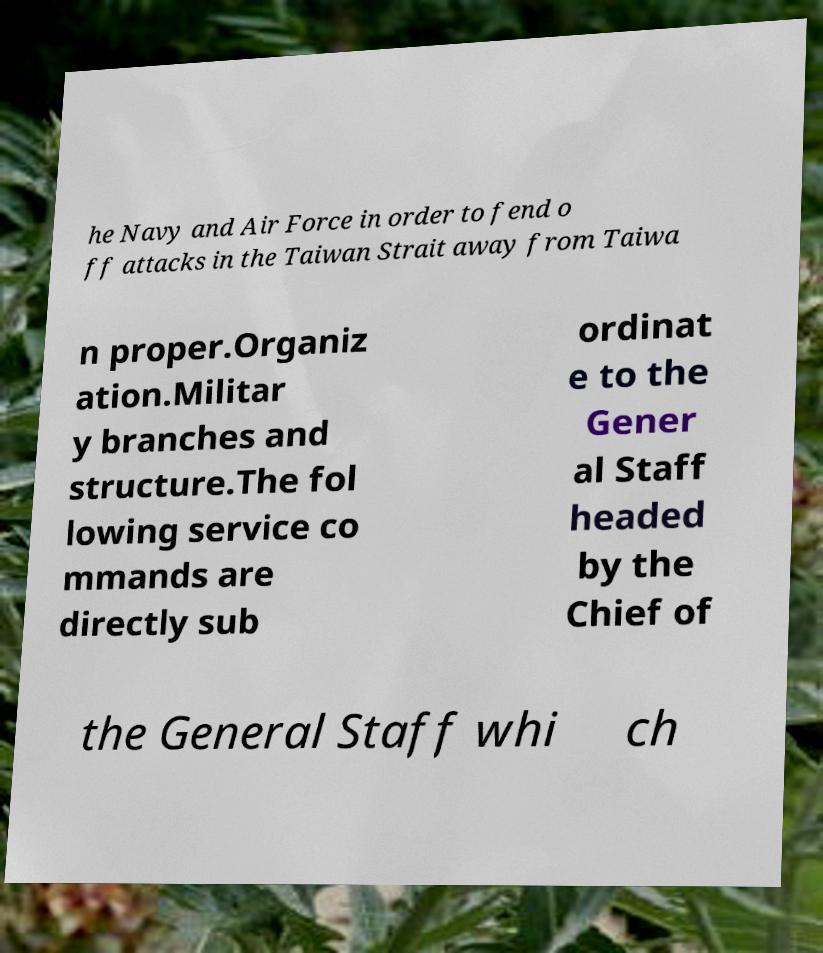Could you extract and type out the text from this image? he Navy and Air Force in order to fend o ff attacks in the Taiwan Strait away from Taiwa n proper.Organiz ation.Militar y branches and structure.The fol lowing service co mmands are directly sub ordinat e to the Gener al Staff headed by the Chief of the General Staff whi ch 